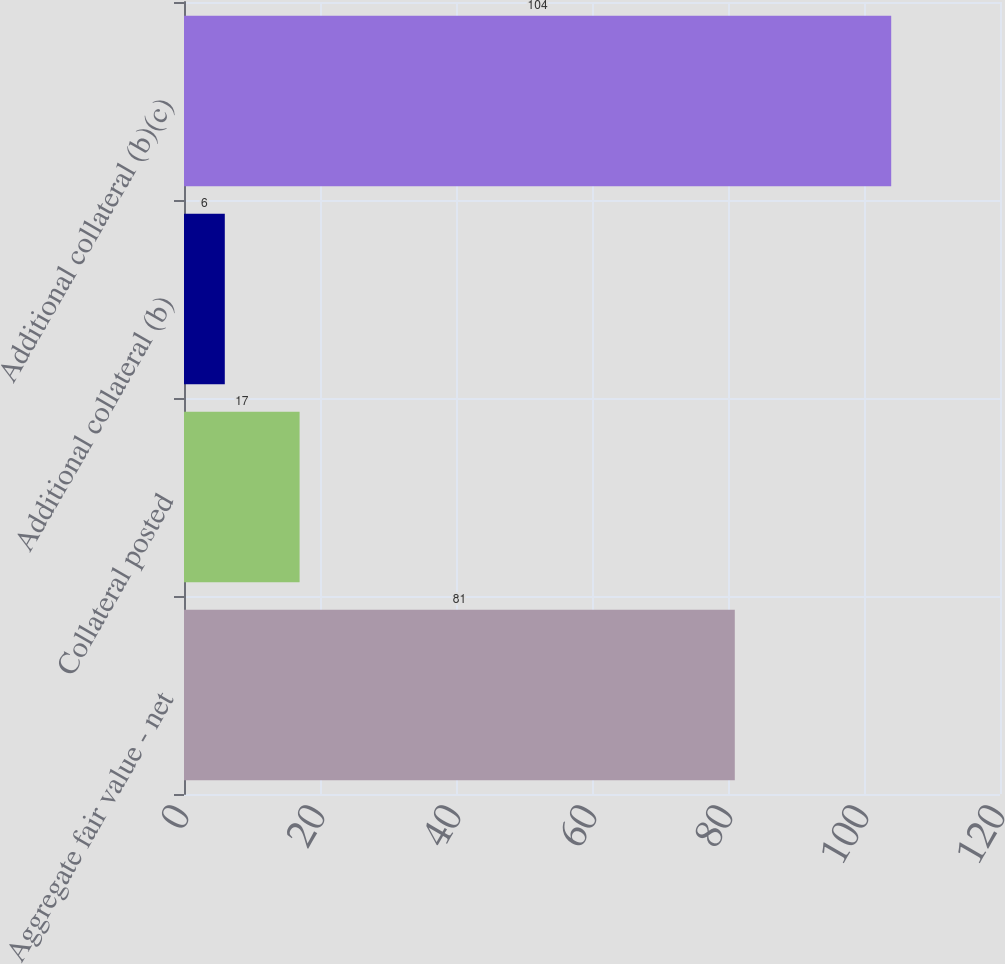Convert chart. <chart><loc_0><loc_0><loc_500><loc_500><bar_chart><fcel>Aggregate fair value - net<fcel>Collateral posted<fcel>Additional collateral (b)<fcel>Additional collateral (b)(c)<nl><fcel>81<fcel>17<fcel>6<fcel>104<nl></chart> 